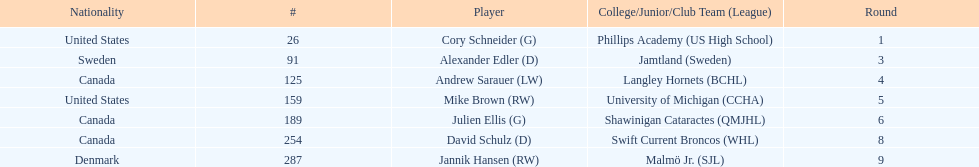What is the name of the last player on this chart? Jannik Hansen (RW). 